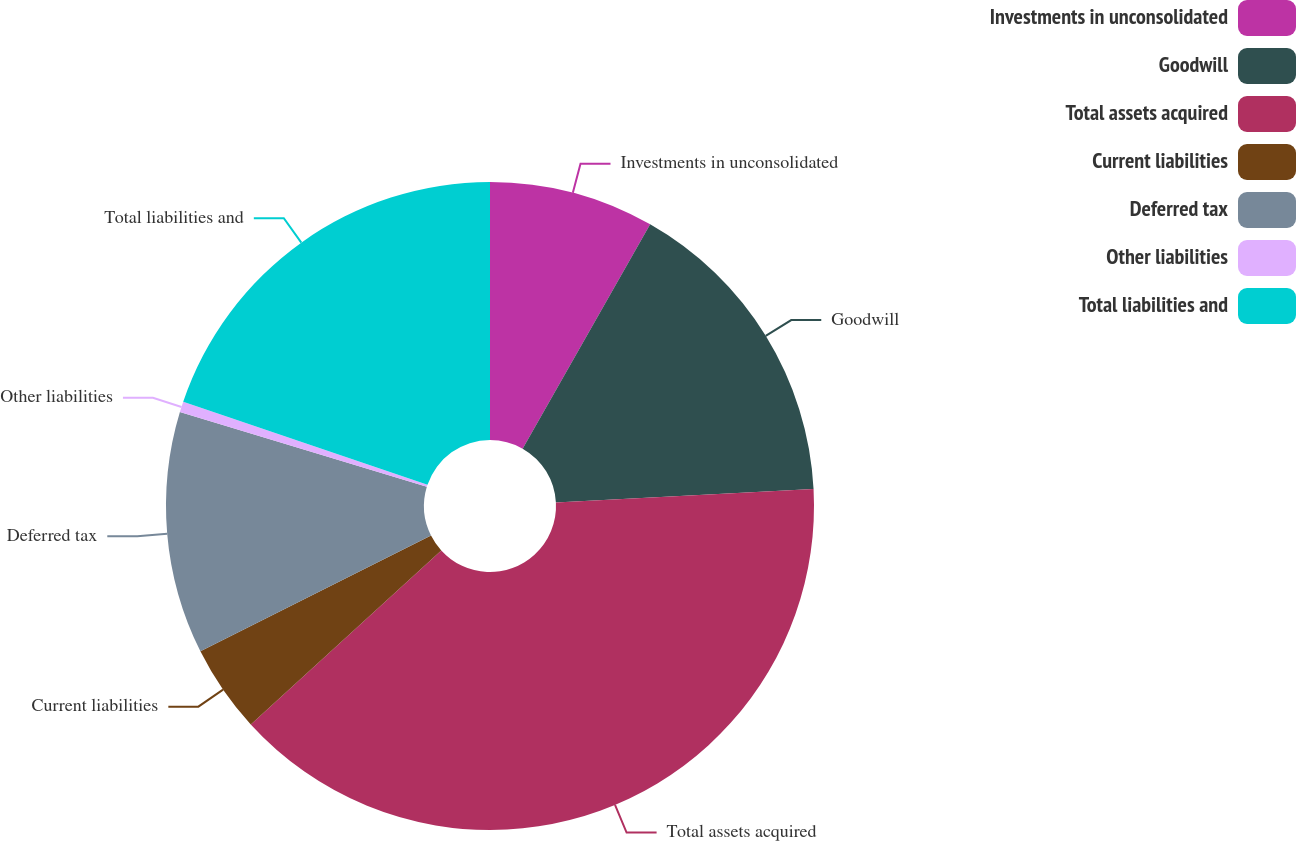Convert chart to OTSL. <chart><loc_0><loc_0><loc_500><loc_500><pie_chart><fcel>Investments in unconsolidated<fcel>Goodwill<fcel>Total assets acquired<fcel>Current liabilities<fcel>Deferred tax<fcel>Other liabilities<fcel>Total liabilities and<nl><fcel>8.23%<fcel>15.94%<fcel>39.05%<fcel>4.38%<fcel>12.08%<fcel>0.53%<fcel>19.79%<nl></chart> 